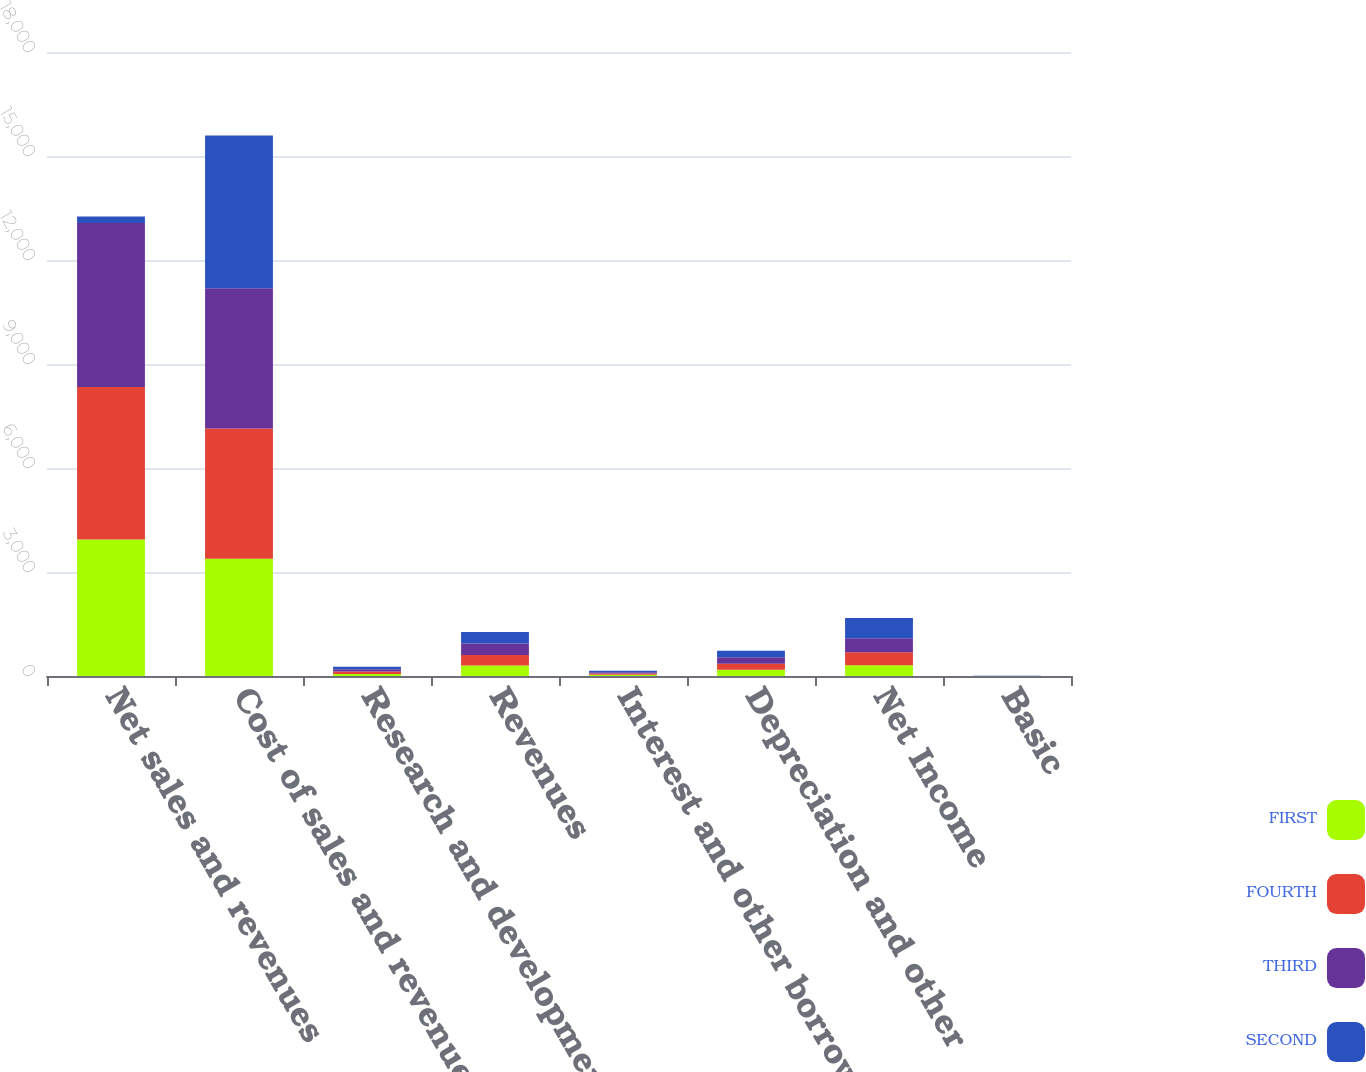<chart> <loc_0><loc_0><loc_500><loc_500><stacked_bar_chart><ecel><fcel>Net sales and revenues<fcel>Cost of sales and revenues<fcel>Research and development<fcel>Revenues<fcel>Interest and other borrowing<fcel>Depreciation and other<fcel>Net Income<fcel>Basic<nl><fcel>FIRST<fcel>3935.7<fcel>3382.2<fcel>61<fcel>302.2<fcel>34.1<fcel>179.7<fcel>310.3<fcel>0.88<nl><fcel>FOURTH<fcel>4397.9<fcel>3755.2<fcel>66.1<fcel>306.3<fcel>37.4<fcel>172.8<fcel>373<fcel>1.06<nl><fcel>THIRD<fcel>4731.5<fcel>4046.8<fcel>67<fcel>328.2<fcel>38.3<fcel>186.2<fcel>402.7<fcel>1.14<nl><fcel>SECOND<fcel>188.8<fcel>4409.5<fcel>70.6<fcel>332.2<fcel>39.8<fcel>188.8<fcel>589.2<fcel>1.67<nl></chart> 